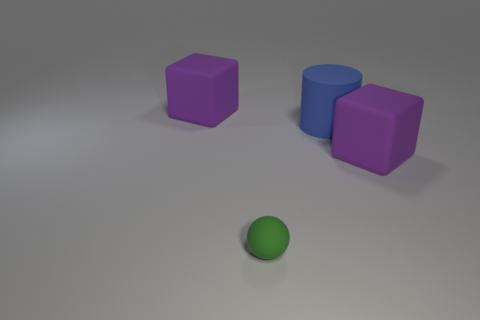Add 4 green rubber things. How many objects exist? 8 Subtract all large gray metallic balls. Subtract all small green matte balls. How many objects are left? 3 Add 1 blue cylinders. How many blue cylinders are left? 2 Add 4 tiny rubber objects. How many tiny rubber objects exist? 5 Subtract 0 green blocks. How many objects are left? 4 Subtract all balls. How many objects are left? 3 